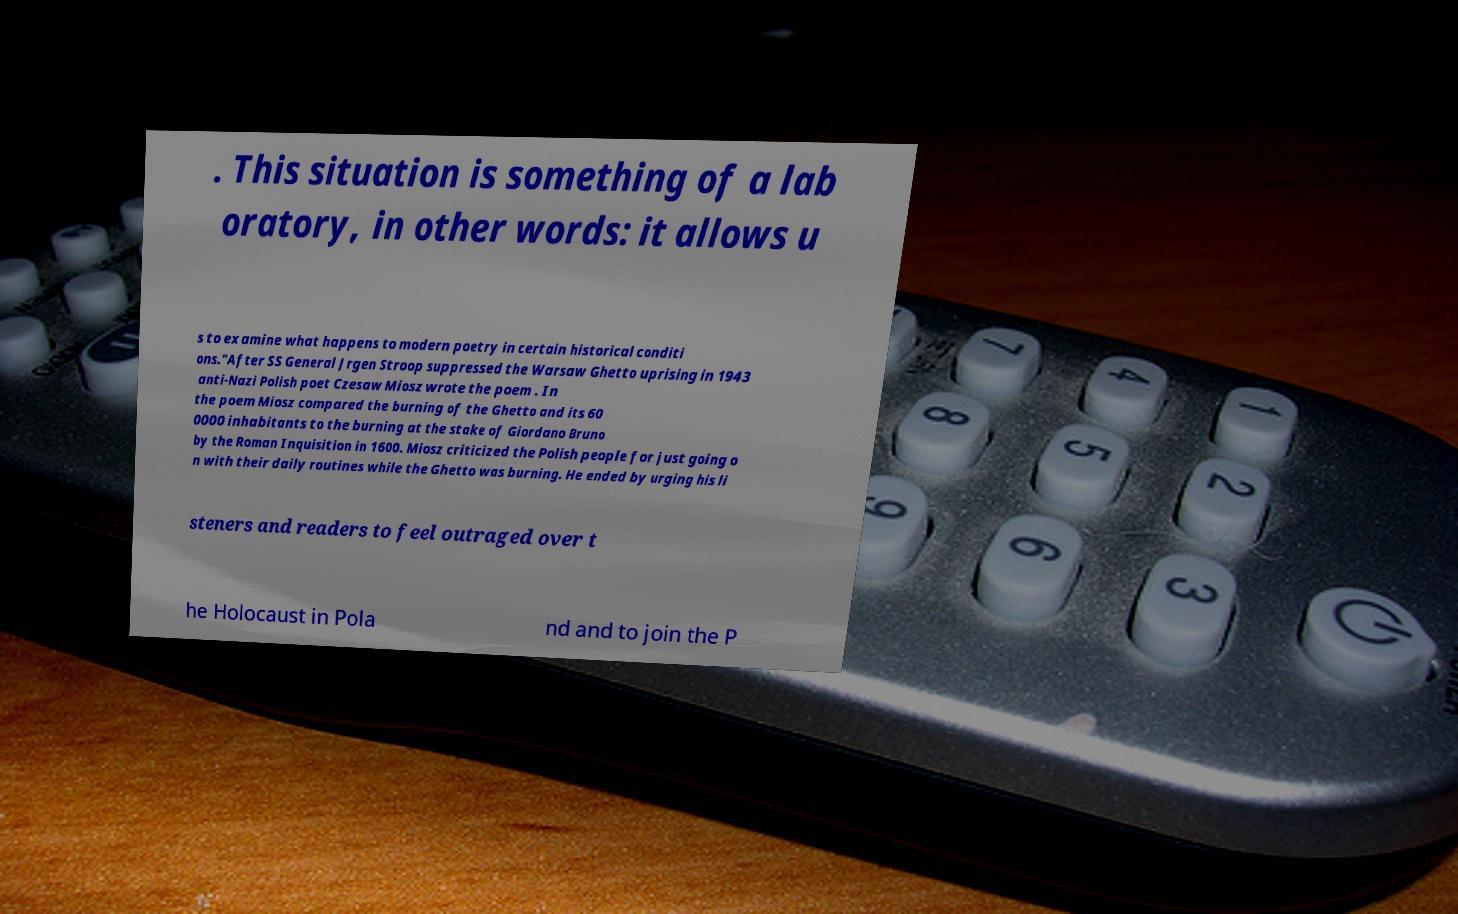What messages or text are displayed in this image? I need them in a readable, typed format. . This situation is something of a lab oratory, in other words: it allows u s to examine what happens to modern poetry in certain historical conditi ons."After SS General Jrgen Stroop suppressed the Warsaw Ghetto uprising in 1943 anti-Nazi Polish poet Czesaw Miosz wrote the poem . In the poem Miosz compared the burning of the Ghetto and its 60 0000 inhabitants to the burning at the stake of Giordano Bruno by the Roman Inquisition in 1600. Miosz criticized the Polish people for just going o n with their daily routines while the Ghetto was burning. He ended by urging his li steners and readers to feel outraged over t he Holocaust in Pola nd and to join the P 